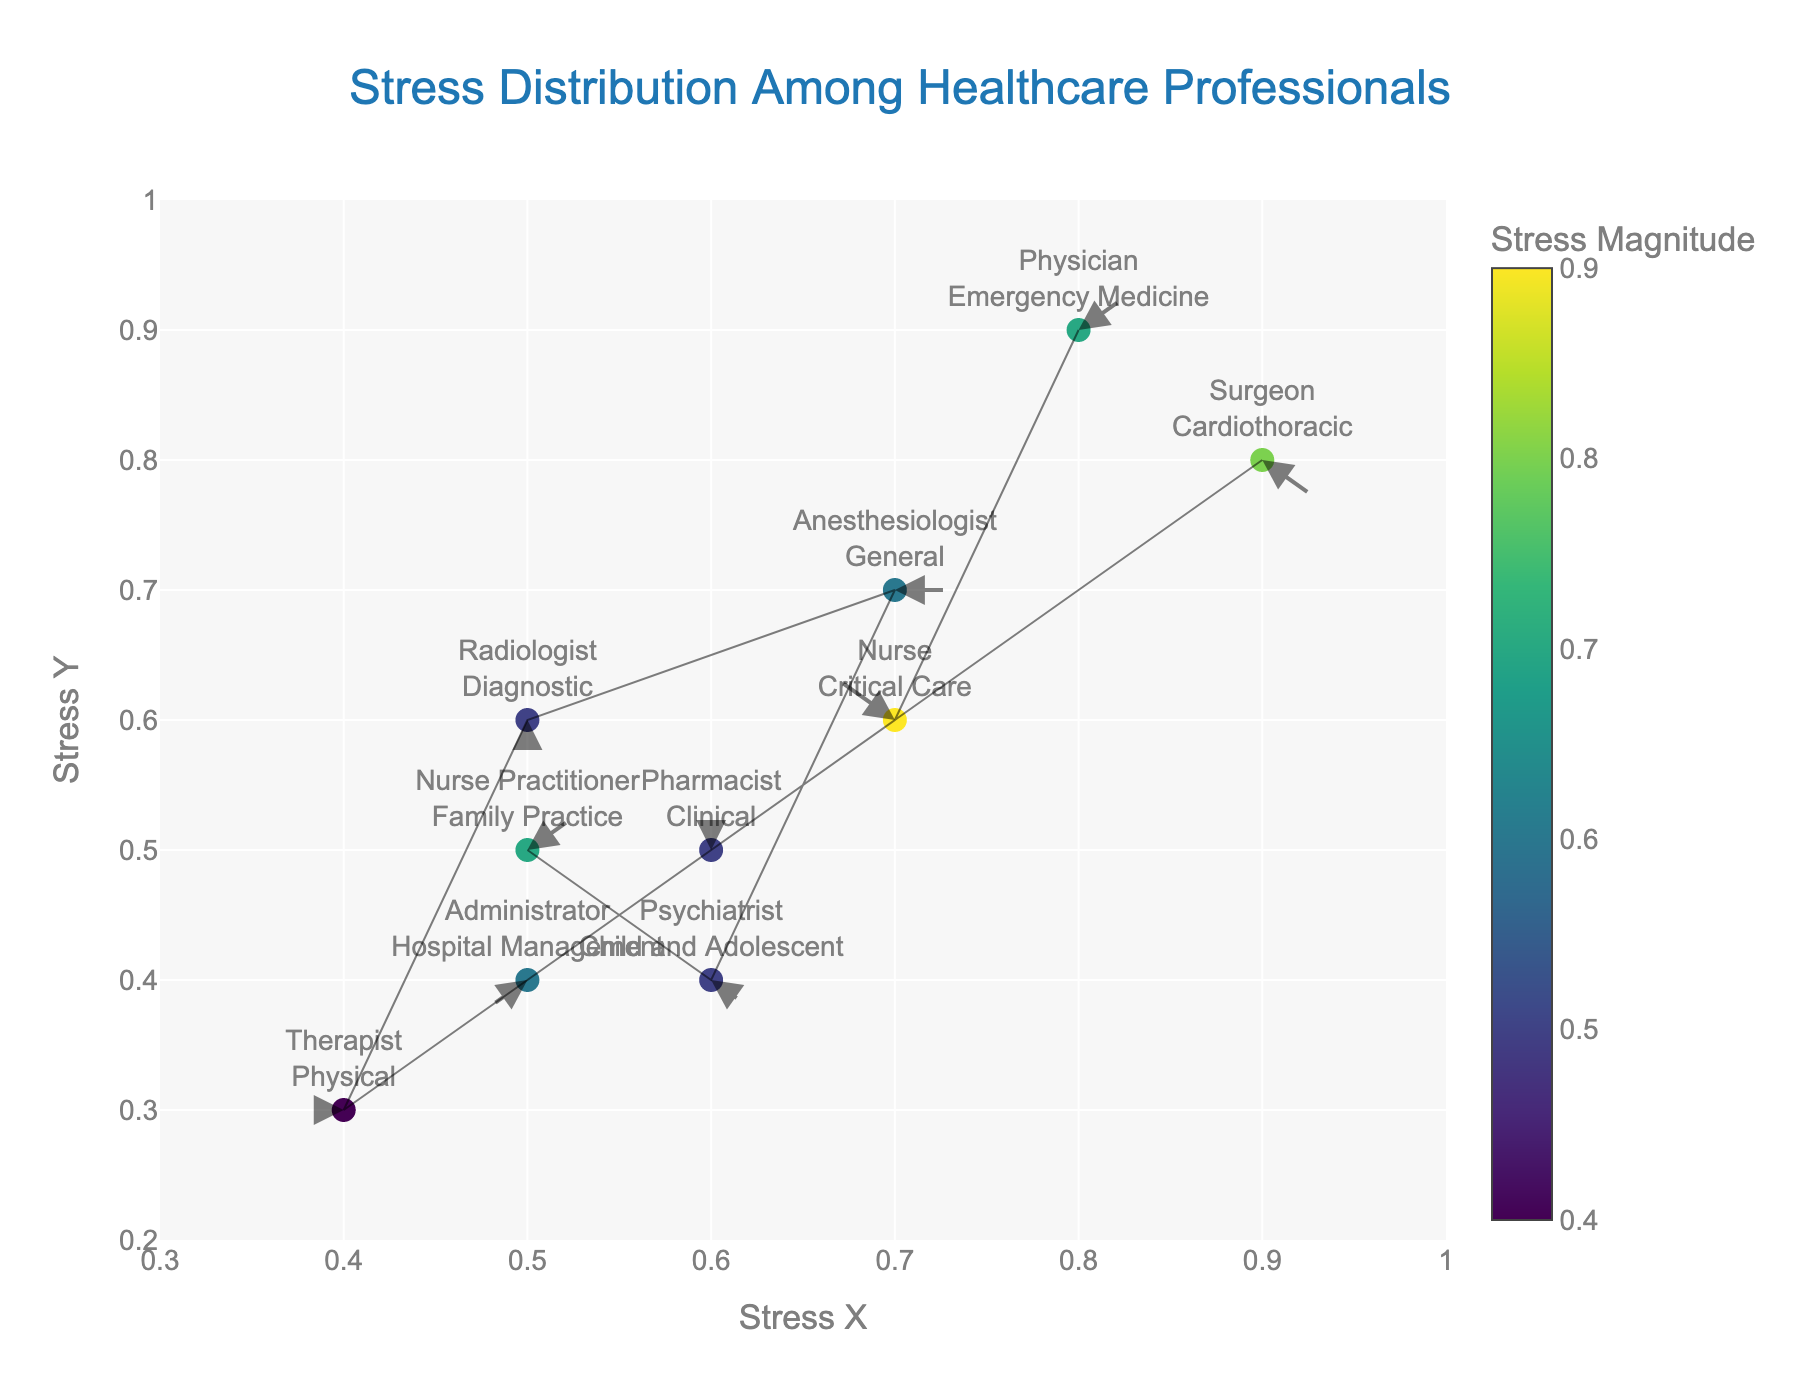What is the title of the figure? The title is usually prominently displayed at the top center of the plot. It helps in understanding the main subject being visualized.
Answer: Stress Distribution Among Healthcare Professionals What are the x and y-axis titles? The axis titles generally appear below the x-axis and to the left of the y-axis. They provide context to what each axis represents. In this plot, the x-axis title is near the bottom of the plot, and the y-axis title is along the left side.
Answer: Stress X (x-axis), Stress Y (y-axis) How many different roles are depicted in the plot? By counting the distinct text labels displayed on the plot, we can determine the number of different roles. Each label represents a unique role.
Answer: 9 Which role shows the highest stress magnitude? The color scale indicates stress magnitude. Identifying the marker with the highest color value and checking its role will reveal this information.
Answer: Nurse (Critical Care) What are the stress vector directions for physicians and anesthesiologists? The direction of stress vectors is indicated by the direction of arrows originating from each marker. By examining the arrows connected to the physician and anesthesiologist markers, we can determine their directions.
Answer: Physician: 45 degrees, Anesthesiologist: 0 degrees Which roles have stress vectors pointing downward? By observing the orientation of the arrows (vectors) associated with each role, those pointing downward will have a direction close to or around 180 degrees.
Answer: Therapist (Physical), Radiologist (Diagnostic) Are the stress vectors of Nurse and Nurse Practitioner moving in the same direction? To answer this, compare the directions of the arrows for both roles. If they point in the same direction, they are moving in the same direction.
Answer: No What is the distance between the stress vectors of Surgeons and Pharmacists? To find this, measure the Euclidean distance between the coordinates of Surgeons and Pharmacists on the plot, using the Stress_X and Stress_Y values. sqrt((Surgeons_Stress_X - Pharmacists_Stress_X)^2 + (Surgeons_Stress_Y - Pharmacists_Stress_Y)^2)
Answer: sqrt((0.9 - 0.6)^2 + (0.8 - 0.5)^2) = sqrt(0.18) ≈ 0.424 Which role has a similar stress vector direction to Psychiatrists but differs in magnitude? By comparing the direction and magnitude of the vectors, identify roles with similar directions but differing magnitudes.
Answer: Surgeon (Cardiothoracic) Which specialty exhibits the lowest stress magnitude and what is it? By examining the color scale on the color bar mapped to magnitude and identifying the marker with the lowest value, check the corresponding specialty.
Answer: Therapist (Physical) with a magnitude of 0.4 